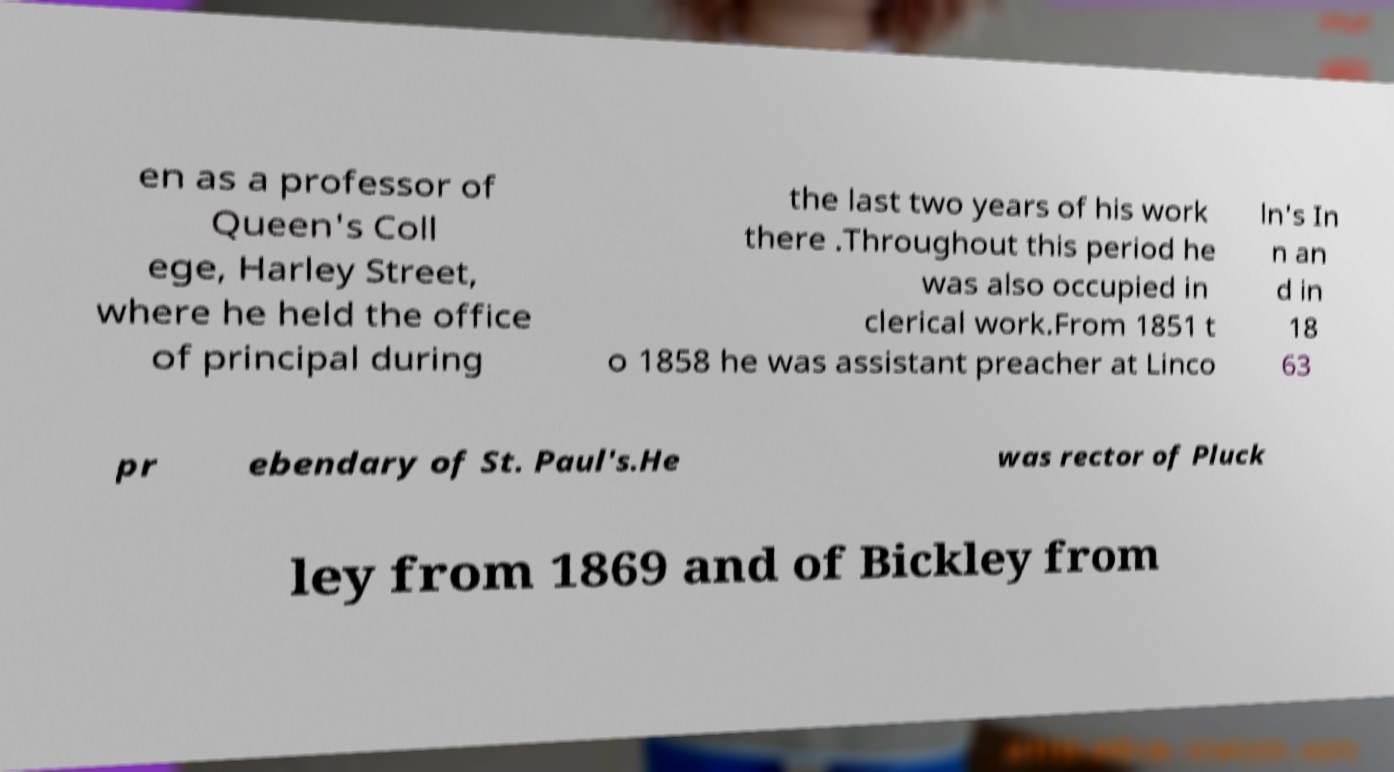What messages or text are displayed in this image? I need them in a readable, typed format. en as a professor of Queen's Coll ege, Harley Street, where he held the office of principal during the last two years of his work there .Throughout this period he was also occupied in clerical work.From 1851 t o 1858 he was assistant preacher at Linco ln's In n an d in 18 63 pr ebendary of St. Paul's.He was rector of Pluck ley from 1869 and of Bickley from 